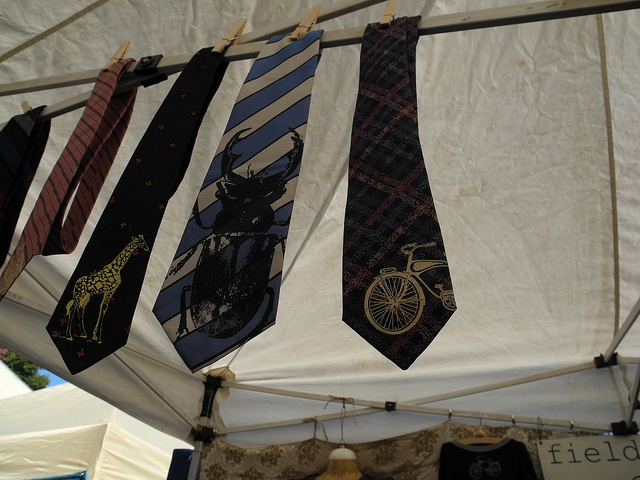Describe the objects in this image and their specific colors. I can see tie in gray and black tones, tie in gray, black, and maroon tones, tie in gray, black, olive, and darkgray tones, tie in gray, black, and maroon tones, and tie in gray, black, and darkgray tones in this image. 